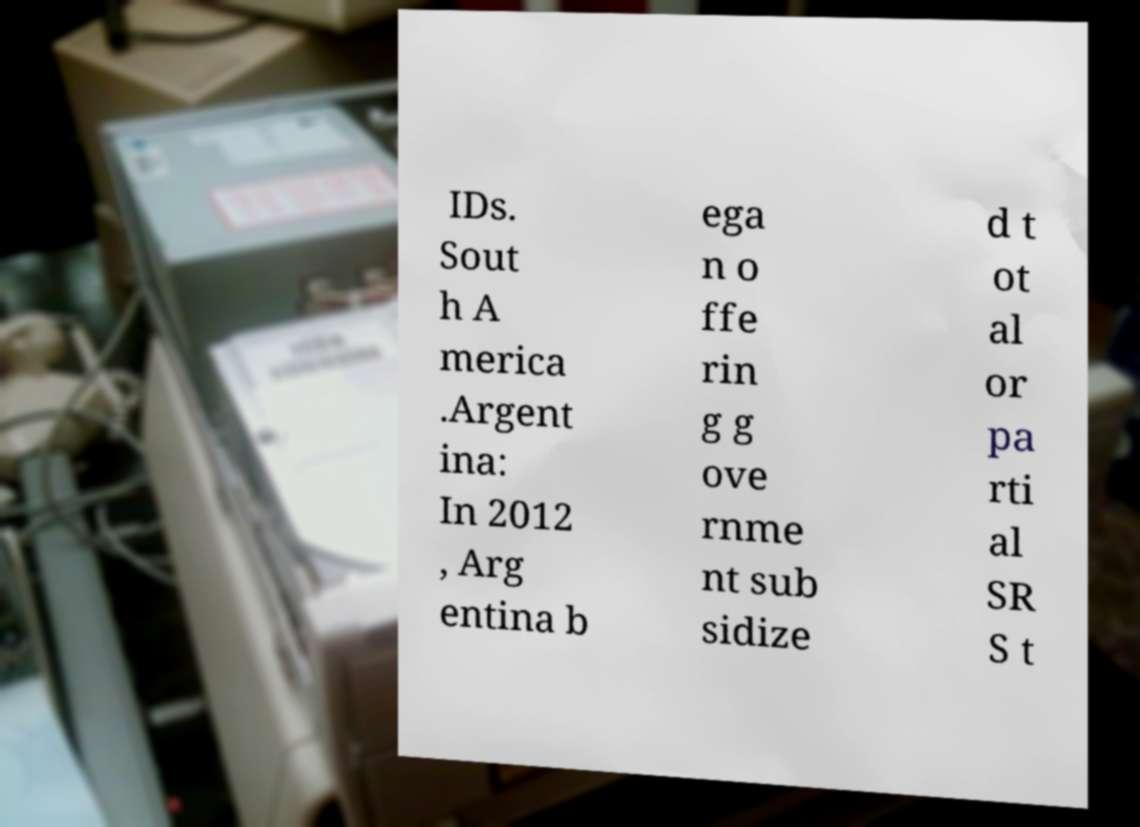Please identify and transcribe the text found in this image. IDs. Sout h A merica .Argent ina: In 2012 , Arg entina b ega n o ffe rin g g ove rnme nt sub sidize d t ot al or pa rti al SR S t 